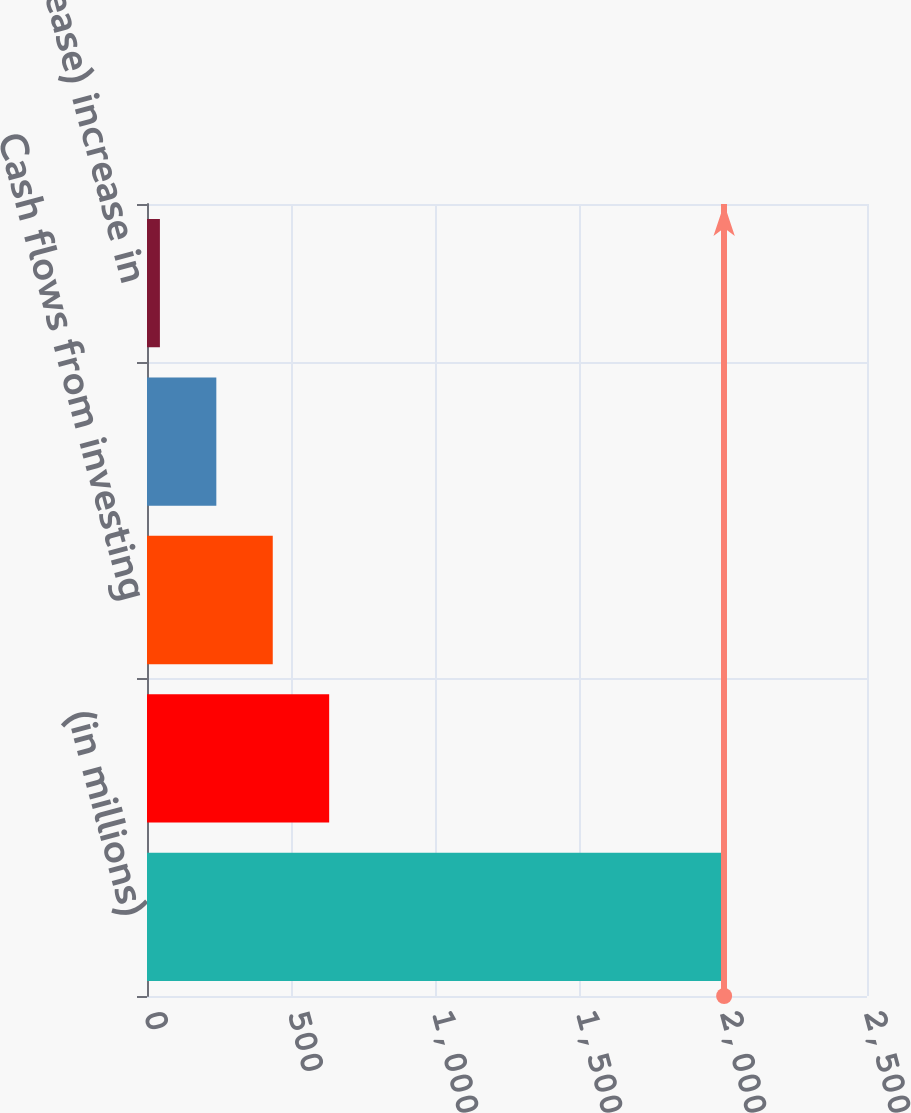<chart> <loc_0><loc_0><loc_500><loc_500><bar_chart><fcel>(in millions)<fcel>Cash flows from operating<fcel>Cash flows from investing<fcel>Cash flows from financing<fcel>Net (decrease) increase in<nl><fcel>2004<fcel>632.56<fcel>436.64<fcel>240.72<fcel>44.8<nl></chart> 